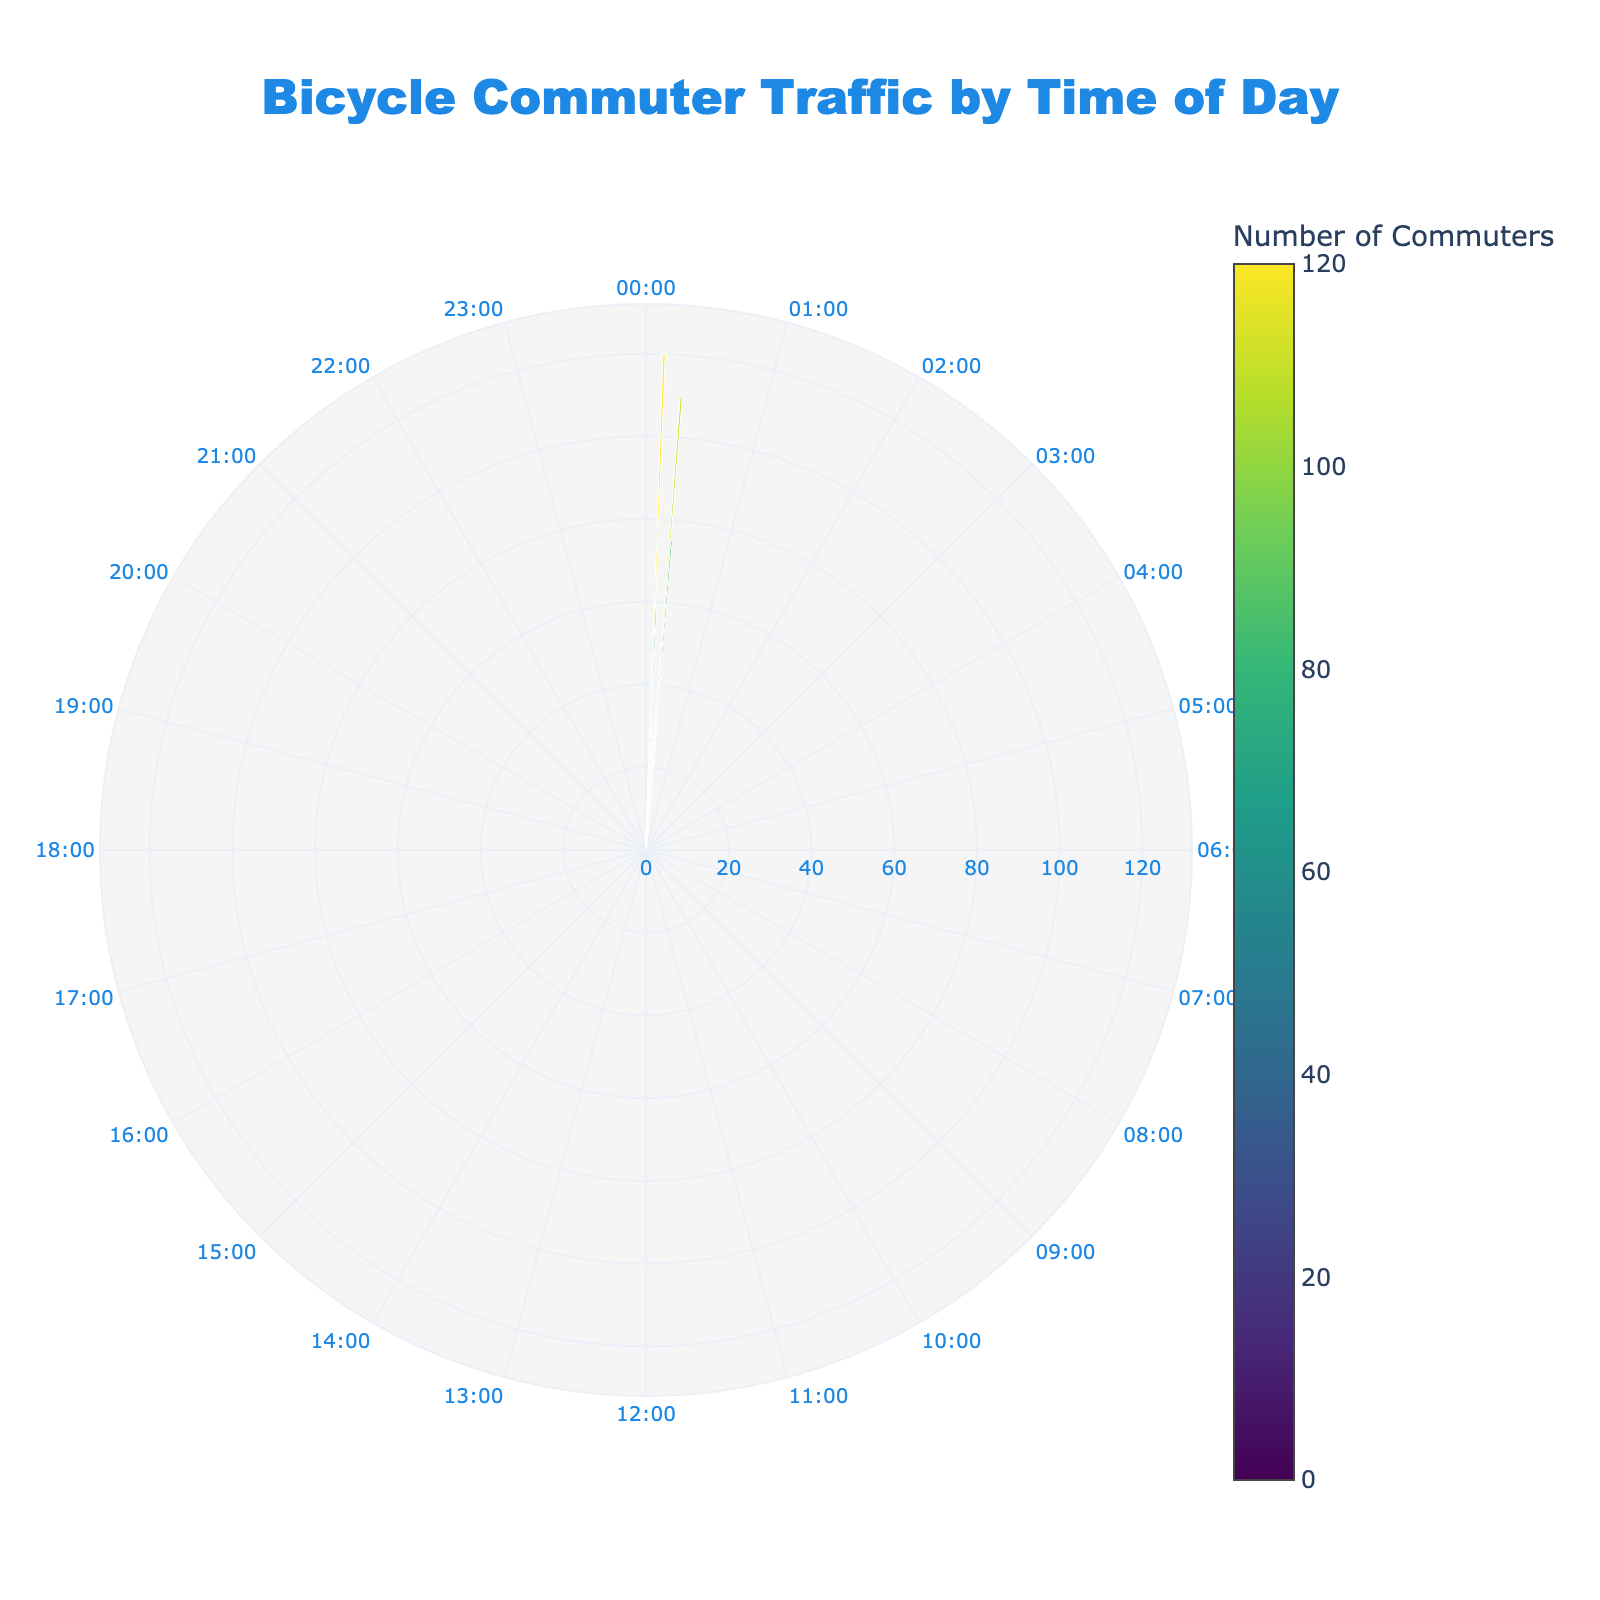What's the title of the chart? The title is typically located at the top of the chart. In this case, it reads "Bicycle Commuter Traffic by Time of Day".
Answer: Bicycle Commuter Traffic by Time of Day What time of day has the highest number of bicycle commuters? By looking at the radial lengths of each bar, we can see that the time with the longest bar is 08:00, indicating it has the highest number of commuters.
Answer: 08:00 How many commuters are there at 17:00? Find the bar corresponding to the 17:00 position on the chart and read its radial length, which indicates the number of commuters. The value is labeled as 110.
Answer: 110 During which hours is bicycle commuting traffic zero? Identify any hours on the chart where the radial length of the bar is 0. This is the case for 03:00.
Answer: 03:00 What is the total number of bicycle commuters between 07:00 and 09:00? Sum the values of the bars corresponding to the hours 07:00, 08:00, and 09:00. These values are 45 (07:00) + 120 (08:00) + 60 (09:00) = 225.
Answer: 225 What is the average number of bicycle commuters between 12:00 and 14:00? Sum the number of commuters for 12:00, 13:00, and 14:00, and then divide by 3. The numbers are 28 (12:00) + 27 (13:00) + 32 (14:00) = 87, so the average is 87 / 3 = 29.
Answer: 29 Which time interval sees the biggest drop in commuter numbers? Calculate the differences in commuter numbers between consecutive hours and identify the interval with the largest decrease. The largest drop happens from 08:00 (120) to 09:00 (60), a decrease of 60 commuters.
Answer: 08:00 to 09:00 At what time do commuter numbers start to significantly increase in the morning? Look for the first hour in the morning where the number of commuters shows a notable rise compared to the previous hour. This significant increase starts at 06:00 with a value of 15, jumping to 45 at 07:00.
Answer: 06:00 Which periods are busier for commuting, morning (04:00-12:00) or evening (16:00-00:00)? Sum the number of commuters for the morning and evening periods. Morning: 2 (04:00) + 5 (05:00) + 15 (06:00) + 45 (07:00) + 120 (08:00) + 60 (09:00) + 30 (10:00) + 25 (11:00) + 28 (12:00) = 330. Evening: 50 (16:00) + 110 (17:00) + 75 (18:00) + 50 (19:00) + 20 (20:00) + 15 (21:00) + 10 (22:00) + 6 (23:00) = 336.
Answer: Evening How does the commuter traffic at 20:00 compare with 18:00? Compare the lengths of the bars at 20:00 and 18:00. At 20:00, there are 20 commuters, whereas at 18:00, there are 75 commuters. Therefore, 20:00 has fewer commuters than 18:00.
Answer: 20:00 has fewer commuters than 18:00 